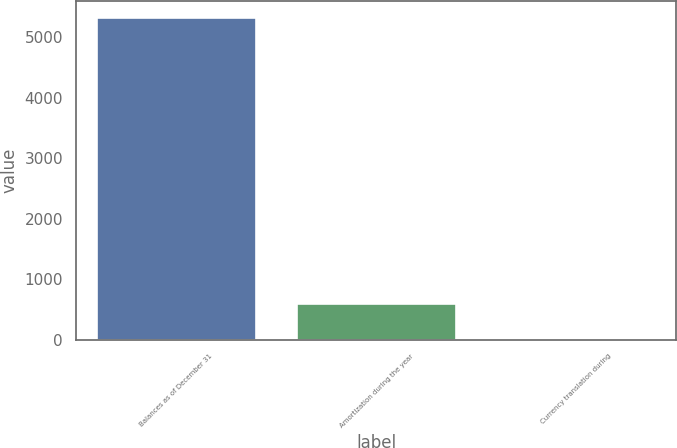Convert chart. <chart><loc_0><loc_0><loc_500><loc_500><bar_chart><fcel>Balances as of December 31<fcel>Amortization during the year<fcel>Currency translation during<nl><fcel>5331<fcel>612.9<fcel>5<nl></chart> 